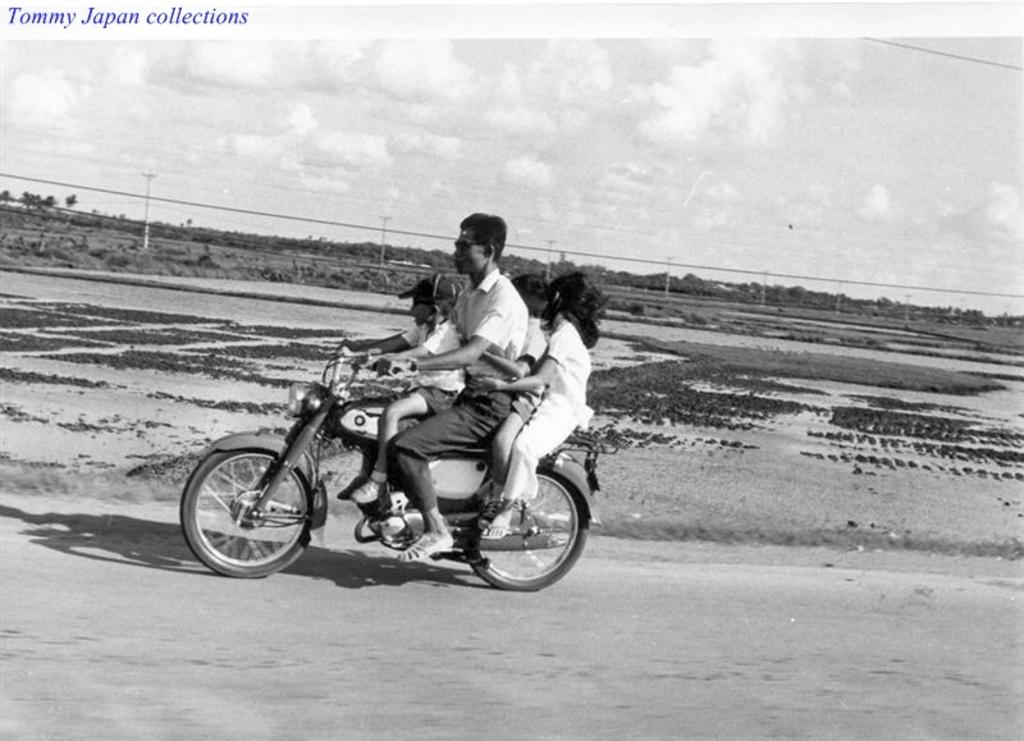What is the main subject of the image? There is a person riding a motorcycle in the image. How many people are on the motorcycle? There are four people seated on the vehicle. What can be seen in the background of the image? There are trees visible in the background. Where is the grandmother sitting with the monkey on the motorcycle? There is no grandmother or monkey present in the image. 